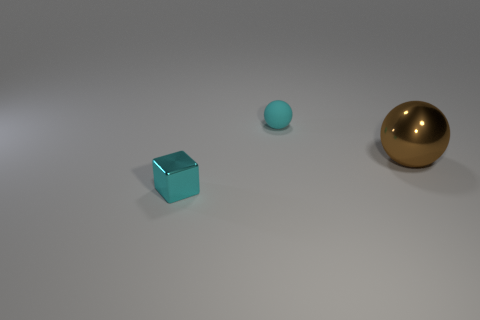Are there any tiny blocks that have the same color as the tiny matte thing?
Keep it short and to the point. Yes. Do the shiny ball and the cyan object behind the large shiny sphere have the same size?
Your response must be concise. No. There is a cyan thing that is in front of the large metallic sphere to the right of the cyan rubber thing; how many cyan cubes are behind it?
Your answer should be compact. 0. What size is the sphere that is the same color as the cube?
Offer a very short reply. Small. There is a tiny metal block; are there any objects right of it?
Make the answer very short. Yes. The big brown thing has what shape?
Give a very brief answer. Sphere. What shape is the metal object that is on the left side of the tiny thing that is right of the small metallic cube that is left of the big brown metal thing?
Ensure brevity in your answer.  Cube. What number of other things are there of the same shape as the cyan shiny thing?
Provide a short and direct response. 0. There is a small thing in front of the big shiny thing behind the block; what is its material?
Give a very brief answer. Metal. Is there any other thing that has the same size as the brown metal ball?
Offer a terse response. No. 